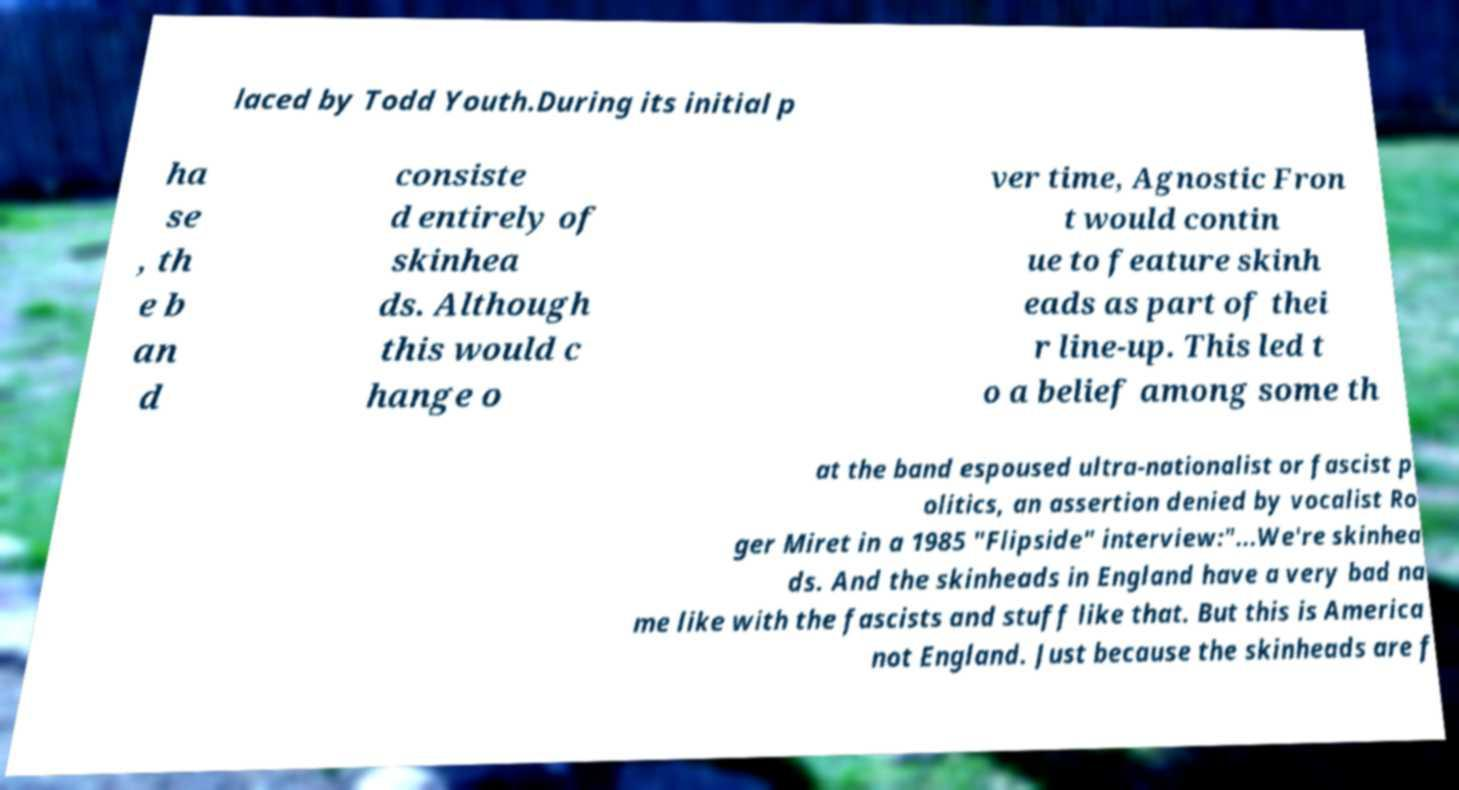What messages or text are displayed in this image? I need them in a readable, typed format. laced by Todd Youth.During its initial p ha se , th e b an d consiste d entirely of skinhea ds. Although this would c hange o ver time, Agnostic Fron t would contin ue to feature skinh eads as part of thei r line-up. This led t o a belief among some th at the band espoused ultra-nationalist or fascist p olitics, an assertion denied by vocalist Ro ger Miret in a 1985 "Flipside" interview:"...We're skinhea ds. And the skinheads in England have a very bad na me like with the fascists and stuff like that. But this is America not England. Just because the skinheads are f 